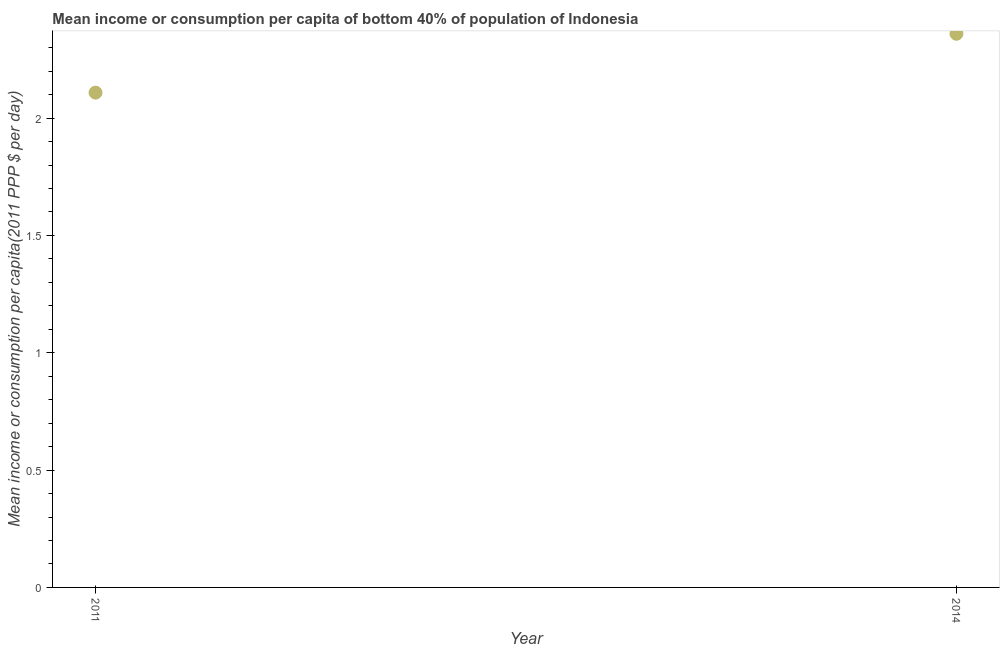What is the mean income or consumption in 2014?
Provide a succinct answer. 2.36. Across all years, what is the maximum mean income or consumption?
Your answer should be compact. 2.36. Across all years, what is the minimum mean income or consumption?
Your response must be concise. 2.11. In which year was the mean income or consumption minimum?
Your response must be concise. 2011. What is the sum of the mean income or consumption?
Keep it short and to the point. 4.47. What is the difference between the mean income or consumption in 2011 and 2014?
Your answer should be compact. -0.25. What is the average mean income or consumption per year?
Your answer should be compact. 2.23. What is the median mean income or consumption?
Provide a succinct answer. 2.23. Do a majority of the years between 2011 and 2014 (inclusive) have mean income or consumption greater than 1.3 $?
Make the answer very short. Yes. What is the ratio of the mean income or consumption in 2011 to that in 2014?
Offer a terse response. 0.89. How many years are there in the graph?
Provide a succinct answer. 2. Are the values on the major ticks of Y-axis written in scientific E-notation?
Offer a very short reply. No. Does the graph contain grids?
Provide a short and direct response. No. What is the title of the graph?
Offer a very short reply. Mean income or consumption per capita of bottom 40% of population of Indonesia. What is the label or title of the Y-axis?
Give a very brief answer. Mean income or consumption per capita(2011 PPP $ per day). What is the Mean income or consumption per capita(2011 PPP $ per day) in 2011?
Ensure brevity in your answer.  2.11. What is the Mean income or consumption per capita(2011 PPP $ per day) in 2014?
Make the answer very short. 2.36. What is the difference between the Mean income or consumption per capita(2011 PPP $ per day) in 2011 and 2014?
Keep it short and to the point. -0.25. What is the ratio of the Mean income or consumption per capita(2011 PPP $ per day) in 2011 to that in 2014?
Offer a terse response. 0.89. 